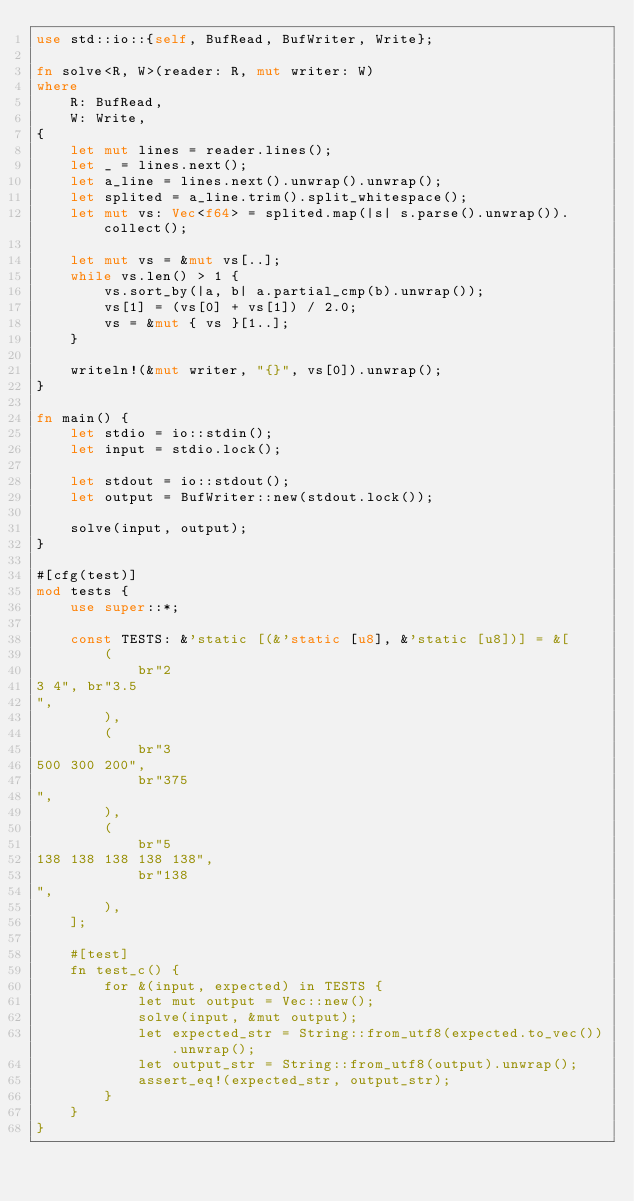Convert code to text. <code><loc_0><loc_0><loc_500><loc_500><_Rust_>use std::io::{self, BufRead, BufWriter, Write};

fn solve<R, W>(reader: R, mut writer: W)
where
    R: BufRead,
    W: Write,
{
    let mut lines = reader.lines();
    let _ = lines.next();
    let a_line = lines.next().unwrap().unwrap();
    let splited = a_line.trim().split_whitespace();
    let mut vs: Vec<f64> = splited.map(|s| s.parse().unwrap()).collect();

    let mut vs = &mut vs[..];
    while vs.len() > 1 {
        vs.sort_by(|a, b| a.partial_cmp(b).unwrap());
        vs[1] = (vs[0] + vs[1]) / 2.0;
        vs = &mut { vs }[1..];
    }

    writeln!(&mut writer, "{}", vs[0]).unwrap();
}

fn main() {
    let stdio = io::stdin();
    let input = stdio.lock();

    let stdout = io::stdout();
    let output = BufWriter::new(stdout.lock());

    solve(input, output);
}

#[cfg(test)]
mod tests {
    use super::*;

    const TESTS: &'static [(&'static [u8], &'static [u8])] = &[
        (
            br"2
3 4", br"3.5
",
        ),
        (
            br"3
500 300 200",
            br"375
",
        ),
        (
            br"5
138 138 138 138 138",
            br"138
",
        ),
    ];

    #[test]
    fn test_c() {
        for &(input, expected) in TESTS {
            let mut output = Vec::new();
            solve(input, &mut output);
            let expected_str = String::from_utf8(expected.to_vec()).unwrap();
            let output_str = String::from_utf8(output).unwrap();
            assert_eq!(expected_str, output_str);
        }
    }
}
</code> 